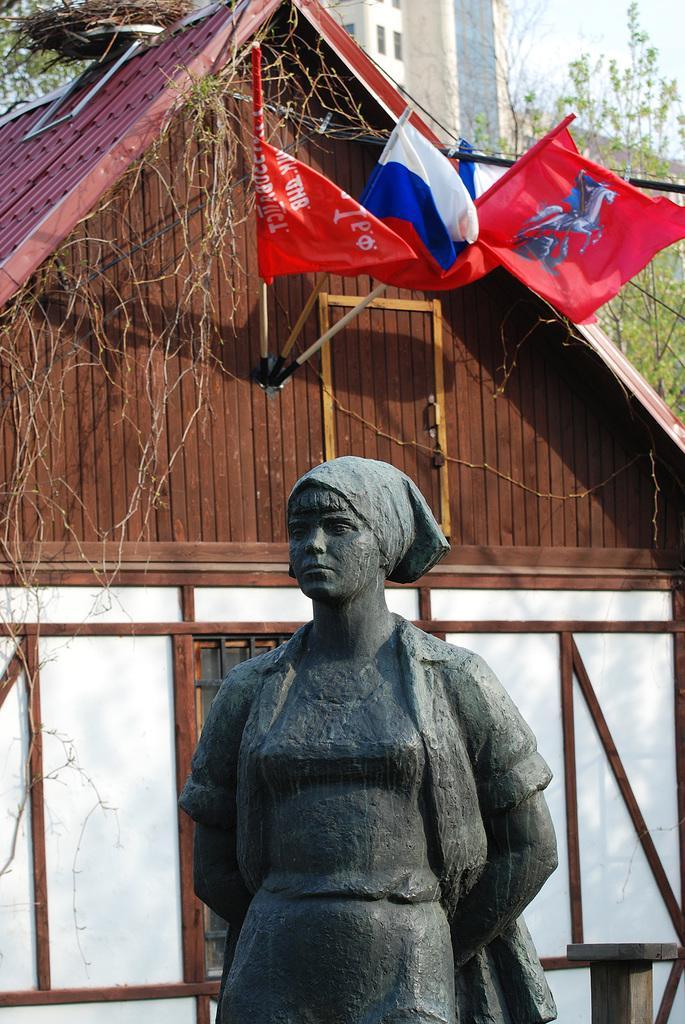How would you summarize this image in a sentence or two? In this image I can see a person's statue, house, flags and trees. In the background I can see buildings and the sky. This image is taken during a day. 